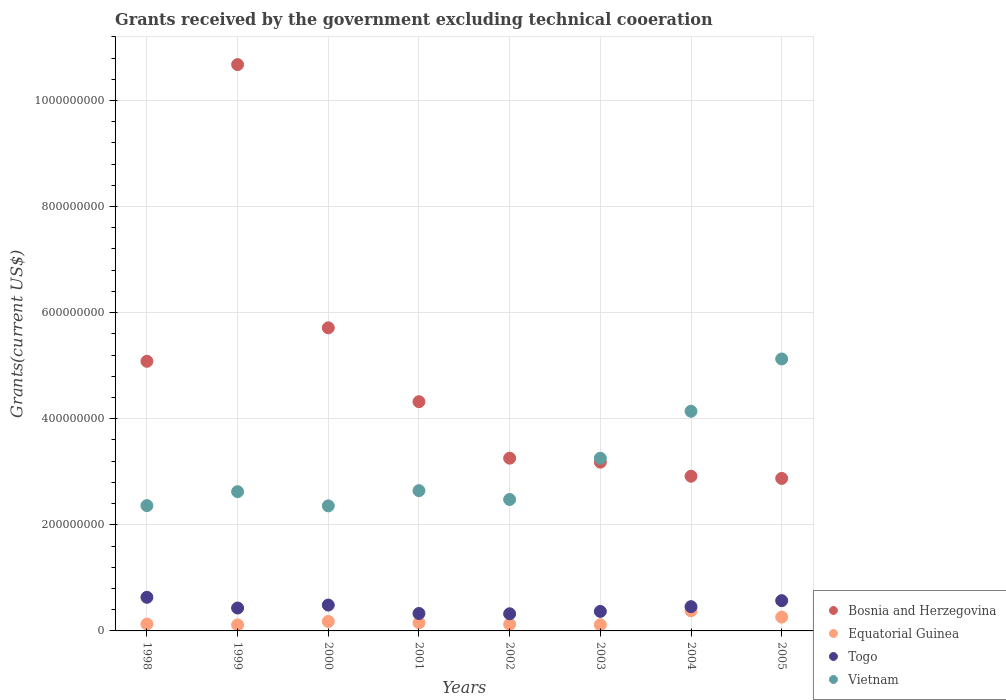What is the total grants received by the government in Vietnam in 1998?
Offer a terse response. 2.36e+08. Across all years, what is the maximum total grants received by the government in Equatorial Guinea?
Ensure brevity in your answer.  3.79e+07. Across all years, what is the minimum total grants received by the government in Vietnam?
Offer a terse response. 2.36e+08. In which year was the total grants received by the government in Togo maximum?
Offer a terse response. 1998. What is the total total grants received by the government in Equatorial Guinea in the graph?
Offer a terse response. 1.46e+08. What is the difference between the total grants received by the government in Vietnam in 1998 and that in 2001?
Make the answer very short. -2.82e+07. What is the difference between the total grants received by the government in Togo in 2003 and the total grants received by the government in Vietnam in 2000?
Offer a terse response. -1.99e+08. What is the average total grants received by the government in Vietnam per year?
Make the answer very short. 3.12e+08. In the year 2004, what is the difference between the total grants received by the government in Vietnam and total grants received by the government in Equatorial Guinea?
Your response must be concise. 3.76e+08. What is the ratio of the total grants received by the government in Vietnam in 1999 to that in 2004?
Offer a terse response. 0.63. Is the difference between the total grants received by the government in Vietnam in 1999 and 2000 greater than the difference between the total grants received by the government in Equatorial Guinea in 1999 and 2000?
Your response must be concise. Yes. What is the difference between the highest and the second highest total grants received by the government in Bosnia and Herzegovina?
Make the answer very short. 4.96e+08. What is the difference between the highest and the lowest total grants received by the government in Vietnam?
Offer a terse response. 2.77e+08. In how many years, is the total grants received by the government in Vietnam greater than the average total grants received by the government in Vietnam taken over all years?
Your answer should be compact. 3. Is the sum of the total grants received by the government in Bosnia and Herzegovina in 1998 and 2003 greater than the maximum total grants received by the government in Vietnam across all years?
Ensure brevity in your answer.  Yes. Is it the case that in every year, the sum of the total grants received by the government in Bosnia and Herzegovina and total grants received by the government in Vietnam  is greater than the sum of total grants received by the government in Togo and total grants received by the government in Equatorial Guinea?
Offer a very short reply. Yes. Is it the case that in every year, the sum of the total grants received by the government in Vietnam and total grants received by the government in Togo  is greater than the total grants received by the government in Equatorial Guinea?
Provide a short and direct response. Yes. Does the total grants received by the government in Bosnia and Herzegovina monotonically increase over the years?
Offer a terse response. No. How many years are there in the graph?
Make the answer very short. 8. What is the difference between two consecutive major ticks on the Y-axis?
Your response must be concise. 2.00e+08. Does the graph contain grids?
Offer a terse response. Yes. How many legend labels are there?
Your answer should be very brief. 4. How are the legend labels stacked?
Offer a very short reply. Vertical. What is the title of the graph?
Provide a succinct answer. Grants received by the government excluding technical cooeration. What is the label or title of the Y-axis?
Give a very brief answer. Grants(current US$). What is the Grants(current US$) in Bosnia and Herzegovina in 1998?
Give a very brief answer. 5.08e+08. What is the Grants(current US$) of Equatorial Guinea in 1998?
Your response must be concise. 1.29e+07. What is the Grants(current US$) in Togo in 1998?
Offer a very short reply. 6.34e+07. What is the Grants(current US$) of Vietnam in 1998?
Make the answer very short. 2.36e+08. What is the Grants(current US$) of Bosnia and Herzegovina in 1999?
Keep it short and to the point. 1.07e+09. What is the Grants(current US$) of Equatorial Guinea in 1999?
Give a very brief answer. 1.13e+07. What is the Grants(current US$) of Togo in 1999?
Offer a terse response. 4.32e+07. What is the Grants(current US$) of Vietnam in 1999?
Ensure brevity in your answer.  2.63e+08. What is the Grants(current US$) of Bosnia and Herzegovina in 2000?
Your answer should be compact. 5.71e+08. What is the Grants(current US$) in Equatorial Guinea in 2000?
Your answer should be very brief. 1.79e+07. What is the Grants(current US$) in Togo in 2000?
Ensure brevity in your answer.  4.88e+07. What is the Grants(current US$) of Vietnam in 2000?
Your response must be concise. 2.36e+08. What is the Grants(current US$) of Bosnia and Herzegovina in 2001?
Provide a short and direct response. 4.32e+08. What is the Grants(current US$) of Equatorial Guinea in 2001?
Your response must be concise. 1.54e+07. What is the Grants(current US$) of Togo in 2001?
Give a very brief answer. 3.29e+07. What is the Grants(current US$) in Vietnam in 2001?
Your answer should be very brief. 2.64e+08. What is the Grants(current US$) in Bosnia and Herzegovina in 2002?
Your response must be concise. 3.26e+08. What is the Grants(current US$) in Equatorial Guinea in 2002?
Keep it short and to the point. 1.25e+07. What is the Grants(current US$) of Togo in 2002?
Make the answer very short. 3.23e+07. What is the Grants(current US$) in Vietnam in 2002?
Provide a succinct answer. 2.48e+08. What is the Grants(current US$) of Bosnia and Herzegovina in 2003?
Ensure brevity in your answer.  3.18e+08. What is the Grants(current US$) of Equatorial Guinea in 2003?
Your response must be concise. 1.16e+07. What is the Grants(current US$) of Togo in 2003?
Your response must be concise. 3.68e+07. What is the Grants(current US$) in Vietnam in 2003?
Your answer should be compact. 3.26e+08. What is the Grants(current US$) of Bosnia and Herzegovina in 2004?
Keep it short and to the point. 2.92e+08. What is the Grants(current US$) in Equatorial Guinea in 2004?
Provide a succinct answer. 3.79e+07. What is the Grants(current US$) in Togo in 2004?
Ensure brevity in your answer.  4.57e+07. What is the Grants(current US$) in Vietnam in 2004?
Offer a terse response. 4.14e+08. What is the Grants(current US$) in Bosnia and Herzegovina in 2005?
Your answer should be compact. 2.88e+08. What is the Grants(current US$) in Equatorial Guinea in 2005?
Keep it short and to the point. 2.61e+07. What is the Grants(current US$) in Togo in 2005?
Your answer should be very brief. 5.70e+07. What is the Grants(current US$) of Vietnam in 2005?
Your answer should be very brief. 5.13e+08. Across all years, what is the maximum Grants(current US$) in Bosnia and Herzegovina?
Make the answer very short. 1.07e+09. Across all years, what is the maximum Grants(current US$) of Equatorial Guinea?
Your answer should be compact. 3.79e+07. Across all years, what is the maximum Grants(current US$) in Togo?
Keep it short and to the point. 6.34e+07. Across all years, what is the maximum Grants(current US$) in Vietnam?
Ensure brevity in your answer.  5.13e+08. Across all years, what is the minimum Grants(current US$) of Bosnia and Herzegovina?
Provide a succinct answer. 2.88e+08. Across all years, what is the minimum Grants(current US$) of Equatorial Guinea?
Provide a succinct answer. 1.13e+07. Across all years, what is the minimum Grants(current US$) in Togo?
Your answer should be compact. 3.23e+07. Across all years, what is the minimum Grants(current US$) in Vietnam?
Provide a succinct answer. 2.36e+08. What is the total Grants(current US$) of Bosnia and Herzegovina in the graph?
Provide a succinct answer. 3.80e+09. What is the total Grants(current US$) of Equatorial Guinea in the graph?
Offer a terse response. 1.46e+08. What is the total Grants(current US$) of Togo in the graph?
Keep it short and to the point. 3.60e+08. What is the total Grants(current US$) of Vietnam in the graph?
Provide a short and direct response. 2.50e+09. What is the difference between the Grants(current US$) of Bosnia and Herzegovina in 1998 and that in 1999?
Your answer should be very brief. -5.59e+08. What is the difference between the Grants(current US$) in Equatorial Guinea in 1998 and that in 1999?
Offer a terse response. 1.65e+06. What is the difference between the Grants(current US$) in Togo in 1998 and that in 1999?
Make the answer very short. 2.02e+07. What is the difference between the Grants(current US$) of Vietnam in 1998 and that in 1999?
Ensure brevity in your answer.  -2.63e+07. What is the difference between the Grants(current US$) of Bosnia and Herzegovina in 1998 and that in 2000?
Your answer should be compact. -6.31e+07. What is the difference between the Grants(current US$) in Equatorial Guinea in 1998 and that in 2000?
Keep it short and to the point. -4.92e+06. What is the difference between the Grants(current US$) of Togo in 1998 and that in 2000?
Make the answer very short. 1.46e+07. What is the difference between the Grants(current US$) in Vietnam in 1998 and that in 2000?
Provide a short and direct response. 5.10e+05. What is the difference between the Grants(current US$) in Bosnia and Herzegovina in 1998 and that in 2001?
Your answer should be very brief. 7.62e+07. What is the difference between the Grants(current US$) of Equatorial Guinea in 1998 and that in 2001?
Provide a succinct answer. -2.46e+06. What is the difference between the Grants(current US$) in Togo in 1998 and that in 2001?
Provide a succinct answer. 3.05e+07. What is the difference between the Grants(current US$) in Vietnam in 1998 and that in 2001?
Offer a terse response. -2.82e+07. What is the difference between the Grants(current US$) of Bosnia and Herzegovina in 1998 and that in 2002?
Your response must be concise. 1.83e+08. What is the difference between the Grants(current US$) of Togo in 1998 and that in 2002?
Keep it short and to the point. 3.11e+07. What is the difference between the Grants(current US$) of Vietnam in 1998 and that in 2002?
Your response must be concise. -1.16e+07. What is the difference between the Grants(current US$) in Bosnia and Herzegovina in 1998 and that in 2003?
Keep it short and to the point. 1.90e+08. What is the difference between the Grants(current US$) in Equatorial Guinea in 1998 and that in 2003?
Your answer should be compact. 1.35e+06. What is the difference between the Grants(current US$) in Togo in 1998 and that in 2003?
Ensure brevity in your answer.  2.66e+07. What is the difference between the Grants(current US$) in Vietnam in 1998 and that in 2003?
Provide a short and direct response. -8.93e+07. What is the difference between the Grants(current US$) in Bosnia and Herzegovina in 1998 and that in 2004?
Ensure brevity in your answer.  2.17e+08. What is the difference between the Grants(current US$) in Equatorial Guinea in 1998 and that in 2004?
Make the answer very short. -2.50e+07. What is the difference between the Grants(current US$) of Togo in 1998 and that in 2004?
Your answer should be compact. 1.76e+07. What is the difference between the Grants(current US$) in Vietnam in 1998 and that in 2004?
Ensure brevity in your answer.  -1.78e+08. What is the difference between the Grants(current US$) of Bosnia and Herzegovina in 1998 and that in 2005?
Your answer should be compact. 2.21e+08. What is the difference between the Grants(current US$) of Equatorial Guinea in 1998 and that in 2005?
Give a very brief answer. -1.31e+07. What is the difference between the Grants(current US$) of Togo in 1998 and that in 2005?
Provide a succinct answer. 6.34e+06. What is the difference between the Grants(current US$) of Vietnam in 1998 and that in 2005?
Offer a terse response. -2.76e+08. What is the difference between the Grants(current US$) in Bosnia and Herzegovina in 1999 and that in 2000?
Your answer should be very brief. 4.96e+08. What is the difference between the Grants(current US$) in Equatorial Guinea in 1999 and that in 2000?
Offer a terse response. -6.57e+06. What is the difference between the Grants(current US$) of Togo in 1999 and that in 2000?
Offer a very short reply. -5.58e+06. What is the difference between the Grants(current US$) of Vietnam in 1999 and that in 2000?
Your answer should be very brief. 2.68e+07. What is the difference between the Grants(current US$) in Bosnia and Herzegovina in 1999 and that in 2001?
Ensure brevity in your answer.  6.35e+08. What is the difference between the Grants(current US$) in Equatorial Guinea in 1999 and that in 2001?
Your answer should be very brief. -4.11e+06. What is the difference between the Grants(current US$) in Togo in 1999 and that in 2001?
Ensure brevity in your answer.  1.03e+07. What is the difference between the Grants(current US$) in Vietnam in 1999 and that in 2001?
Give a very brief answer. -1.88e+06. What is the difference between the Grants(current US$) of Bosnia and Herzegovina in 1999 and that in 2002?
Keep it short and to the point. 7.42e+08. What is the difference between the Grants(current US$) of Equatorial Guinea in 1999 and that in 2002?
Provide a succinct answer. -1.17e+06. What is the difference between the Grants(current US$) in Togo in 1999 and that in 2002?
Offer a terse response. 1.09e+07. What is the difference between the Grants(current US$) in Vietnam in 1999 and that in 2002?
Give a very brief answer. 1.48e+07. What is the difference between the Grants(current US$) of Bosnia and Herzegovina in 1999 and that in 2003?
Provide a short and direct response. 7.49e+08. What is the difference between the Grants(current US$) in Equatorial Guinea in 1999 and that in 2003?
Make the answer very short. -3.00e+05. What is the difference between the Grants(current US$) in Togo in 1999 and that in 2003?
Make the answer very short. 6.42e+06. What is the difference between the Grants(current US$) in Vietnam in 1999 and that in 2003?
Offer a very short reply. -6.30e+07. What is the difference between the Grants(current US$) in Bosnia and Herzegovina in 1999 and that in 2004?
Your answer should be compact. 7.76e+08. What is the difference between the Grants(current US$) in Equatorial Guinea in 1999 and that in 2004?
Provide a short and direct response. -2.66e+07. What is the difference between the Grants(current US$) in Togo in 1999 and that in 2004?
Ensure brevity in your answer.  -2.55e+06. What is the difference between the Grants(current US$) in Vietnam in 1999 and that in 2004?
Provide a short and direct response. -1.52e+08. What is the difference between the Grants(current US$) in Bosnia and Herzegovina in 1999 and that in 2005?
Provide a succinct answer. 7.80e+08. What is the difference between the Grants(current US$) of Equatorial Guinea in 1999 and that in 2005?
Provide a short and direct response. -1.48e+07. What is the difference between the Grants(current US$) in Togo in 1999 and that in 2005?
Offer a terse response. -1.39e+07. What is the difference between the Grants(current US$) of Vietnam in 1999 and that in 2005?
Your answer should be very brief. -2.50e+08. What is the difference between the Grants(current US$) in Bosnia and Herzegovina in 2000 and that in 2001?
Provide a short and direct response. 1.39e+08. What is the difference between the Grants(current US$) in Equatorial Guinea in 2000 and that in 2001?
Offer a very short reply. 2.46e+06. What is the difference between the Grants(current US$) of Togo in 2000 and that in 2001?
Ensure brevity in your answer.  1.59e+07. What is the difference between the Grants(current US$) of Vietnam in 2000 and that in 2001?
Give a very brief answer. -2.87e+07. What is the difference between the Grants(current US$) of Bosnia and Herzegovina in 2000 and that in 2002?
Your answer should be compact. 2.46e+08. What is the difference between the Grants(current US$) of Equatorial Guinea in 2000 and that in 2002?
Offer a terse response. 5.40e+06. What is the difference between the Grants(current US$) in Togo in 2000 and that in 2002?
Your answer should be compact. 1.64e+07. What is the difference between the Grants(current US$) in Vietnam in 2000 and that in 2002?
Offer a very short reply. -1.21e+07. What is the difference between the Grants(current US$) of Bosnia and Herzegovina in 2000 and that in 2003?
Make the answer very short. 2.53e+08. What is the difference between the Grants(current US$) in Equatorial Guinea in 2000 and that in 2003?
Provide a succinct answer. 6.27e+06. What is the difference between the Grants(current US$) of Togo in 2000 and that in 2003?
Make the answer very short. 1.20e+07. What is the difference between the Grants(current US$) in Vietnam in 2000 and that in 2003?
Make the answer very short. -8.98e+07. What is the difference between the Grants(current US$) of Bosnia and Herzegovina in 2000 and that in 2004?
Ensure brevity in your answer.  2.80e+08. What is the difference between the Grants(current US$) of Equatorial Guinea in 2000 and that in 2004?
Keep it short and to the point. -2.00e+07. What is the difference between the Grants(current US$) in Togo in 2000 and that in 2004?
Provide a succinct answer. 3.03e+06. What is the difference between the Grants(current US$) of Vietnam in 2000 and that in 2004?
Give a very brief answer. -1.78e+08. What is the difference between the Grants(current US$) of Bosnia and Herzegovina in 2000 and that in 2005?
Keep it short and to the point. 2.84e+08. What is the difference between the Grants(current US$) in Equatorial Guinea in 2000 and that in 2005?
Provide a succinct answer. -8.20e+06. What is the difference between the Grants(current US$) in Togo in 2000 and that in 2005?
Give a very brief answer. -8.28e+06. What is the difference between the Grants(current US$) in Vietnam in 2000 and that in 2005?
Your answer should be compact. -2.77e+08. What is the difference between the Grants(current US$) in Bosnia and Herzegovina in 2001 and that in 2002?
Offer a terse response. 1.06e+08. What is the difference between the Grants(current US$) in Equatorial Guinea in 2001 and that in 2002?
Your response must be concise. 2.94e+06. What is the difference between the Grants(current US$) of Togo in 2001 and that in 2002?
Your answer should be very brief. 5.50e+05. What is the difference between the Grants(current US$) in Vietnam in 2001 and that in 2002?
Ensure brevity in your answer.  1.66e+07. What is the difference between the Grants(current US$) in Bosnia and Herzegovina in 2001 and that in 2003?
Offer a terse response. 1.14e+08. What is the difference between the Grants(current US$) of Equatorial Guinea in 2001 and that in 2003?
Your response must be concise. 3.81e+06. What is the difference between the Grants(current US$) in Togo in 2001 and that in 2003?
Keep it short and to the point. -3.90e+06. What is the difference between the Grants(current US$) of Vietnam in 2001 and that in 2003?
Keep it short and to the point. -6.11e+07. What is the difference between the Grants(current US$) in Bosnia and Herzegovina in 2001 and that in 2004?
Make the answer very short. 1.40e+08. What is the difference between the Grants(current US$) of Equatorial Guinea in 2001 and that in 2004?
Your answer should be compact. -2.25e+07. What is the difference between the Grants(current US$) in Togo in 2001 and that in 2004?
Make the answer very short. -1.29e+07. What is the difference between the Grants(current US$) in Vietnam in 2001 and that in 2004?
Your answer should be very brief. -1.50e+08. What is the difference between the Grants(current US$) of Bosnia and Herzegovina in 2001 and that in 2005?
Give a very brief answer. 1.45e+08. What is the difference between the Grants(current US$) of Equatorial Guinea in 2001 and that in 2005?
Offer a very short reply. -1.07e+07. What is the difference between the Grants(current US$) of Togo in 2001 and that in 2005?
Provide a succinct answer. -2.42e+07. What is the difference between the Grants(current US$) in Vietnam in 2001 and that in 2005?
Offer a very short reply. -2.48e+08. What is the difference between the Grants(current US$) of Bosnia and Herzegovina in 2002 and that in 2003?
Provide a short and direct response. 7.51e+06. What is the difference between the Grants(current US$) in Equatorial Guinea in 2002 and that in 2003?
Your answer should be very brief. 8.70e+05. What is the difference between the Grants(current US$) in Togo in 2002 and that in 2003?
Your response must be concise. -4.45e+06. What is the difference between the Grants(current US$) in Vietnam in 2002 and that in 2003?
Make the answer very short. -7.77e+07. What is the difference between the Grants(current US$) of Bosnia and Herzegovina in 2002 and that in 2004?
Provide a succinct answer. 3.40e+07. What is the difference between the Grants(current US$) of Equatorial Guinea in 2002 and that in 2004?
Your answer should be very brief. -2.54e+07. What is the difference between the Grants(current US$) in Togo in 2002 and that in 2004?
Provide a succinct answer. -1.34e+07. What is the difference between the Grants(current US$) in Vietnam in 2002 and that in 2004?
Your answer should be compact. -1.66e+08. What is the difference between the Grants(current US$) of Bosnia and Herzegovina in 2002 and that in 2005?
Your answer should be compact. 3.81e+07. What is the difference between the Grants(current US$) of Equatorial Guinea in 2002 and that in 2005?
Keep it short and to the point. -1.36e+07. What is the difference between the Grants(current US$) in Togo in 2002 and that in 2005?
Provide a succinct answer. -2.47e+07. What is the difference between the Grants(current US$) in Vietnam in 2002 and that in 2005?
Give a very brief answer. -2.65e+08. What is the difference between the Grants(current US$) of Bosnia and Herzegovina in 2003 and that in 2004?
Give a very brief answer. 2.65e+07. What is the difference between the Grants(current US$) in Equatorial Guinea in 2003 and that in 2004?
Offer a terse response. -2.63e+07. What is the difference between the Grants(current US$) in Togo in 2003 and that in 2004?
Provide a short and direct response. -8.97e+06. What is the difference between the Grants(current US$) in Vietnam in 2003 and that in 2004?
Your answer should be very brief. -8.85e+07. What is the difference between the Grants(current US$) of Bosnia and Herzegovina in 2003 and that in 2005?
Keep it short and to the point. 3.06e+07. What is the difference between the Grants(current US$) of Equatorial Guinea in 2003 and that in 2005?
Your answer should be compact. -1.45e+07. What is the difference between the Grants(current US$) of Togo in 2003 and that in 2005?
Provide a short and direct response. -2.03e+07. What is the difference between the Grants(current US$) of Vietnam in 2003 and that in 2005?
Provide a short and direct response. -1.87e+08. What is the difference between the Grants(current US$) of Bosnia and Herzegovina in 2004 and that in 2005?
Offer a terse response. 4.10e+06. What is the difference between the Grants(current US$) of Equatorial Guinea in 2004 and that in 2005?
Provide a short and direct response. 1.18e+07. What is the difference between the Grants(current US$) of Togo in 2004 and that in 2005?
Provide a short and direct response. -1.13e+07. What is the difference between the Grants(current US$) of Vietnam in 2004 and that in 2005?
Make the answer very short. -9.86e+07. What is the difference between the Grants(current US$) in Bosnia and Herzegovina in 1998 and the Grants(current US$) in Equatorial Guinea in 1999?
Give a very brief answer. 4.97e+08. What is the difference between the Grants(current US$) of Bosnia and Herzegovina in 1998 and the Grants(current US$) of Togo in 1999?
Provide a succinct answer. 4.65e+08. What is the difference between the Grants(current US$) of Bosnia and Herzegovina in 1998 and the Grants(current US$) of Vietnam in 1999?
Your answer should be compact. 2.46e+08. What is the difference between the Grants(current US$) of Equatorial Guinea in 1998 and the Grants(current US$) of Togo in 1999?
Your answer should be very brief. -3.02e+07. What is the difference between the Grants(current US$) of Equatorial Guinea in 1998 and the Grants(current US$) of Vietnam in 1999?
Provide a short and direct response. -2.50e+08. What is the difference between the Grants(current US$) of Togo in 1998 and the Grants(current US$) of Vietnam in 1999?
Offer a very short reply. -1.99e+08. What is the difference between the Grants(current US$) in Bosnia and Herzegovina in 1998 and the Grants(current US$) in Equatorial Guinea in 2000?
Make the answer very short. 4.90e+08. What is the difference between the Grants(current US$) in Bosnia and Herzegovina in 1998 and the Grants(current US$) in Togo in 2000?
Give a very brief answer. 4.60e+08. What is the difference between the Grants(current US$) in Bosnia and Herzegovina in 1998 and the Grants(current US$) in Vietnam in 2000?
Offer a very short reply. 2.73e+08. What is the difference between the Grants(current US$) of Equatorial Guinea in 1998 and the Grants(current US$) of Togo in 2000?
Provide a short and direct response. -3.58e+07. What is the difference between the Grants(current US$) of Equatorial Guinea in 1998 and the Grants(current US$) of Vietnam in 2000?
Ensure brevity in your answer.  -2.23e+08. What is the difference between the Grants(current US$) of Togo in 1998 and the Grants(current US$) of Vietnam in 2000?
Ensure brevity in your answer.  -1.72e+08. What is the difference between the Grants(current US$) in Bosnia and Herzegovina in 1998 and the Grants(current US$) in Equatorial Guinea in 2001?
Your response must be concise. 4.93e+08. What is the difference between the Grants(current US$) of Bosnia and Herzegovina in 1998 and the Grants(current US$) of Togo in 2001?
Offer a terse response. 4.75e+08. What is the difference between the Grants(current US$) of Bosnia and Herzegovina in 1998 and the Grants(current US$) of Vietnam in 2001?
Provide a succinct answer. 2.44e+08. What is the difference between the Grants(current US$) of Equatorial Guinea in 1998 and the Grants(current US$) of Togo in 2001?
Your response must be concise. -1.99e+07. What is the difference between the Grants(current US$) in Equatorial Guinea in 1998 and the Grants(current US$) in Vietnam in 2001?
Ensure brevity in your answer.  -2.51e+08. What is the difference between the Grants(current US$) in Togo in 1998 and the Grants(current US$) in Vietnam in 2001?
Provide a succinct answer. -2.01e+08. What is the difference between the Grants(current US$) of Bosnia and Herzegovina in 1998 and the Grants(current US$) of Equatorial Guinea in 2002?
Your response must be concise. 4.96e+08. What is the difference between the Grants(current US$) in Bosnia and Herzegovina in 1998 and the Grants(current US$) in Togo in 2002?
Ensure brevity in your answer.  4.76e+08. What is the difference between the Grants(current US$) in Bosnia and Herzegovina in 1998 and the Grants(current US$) in Vietnam in 2002?
Give a very brief answer. 2.61e+08. What is the difference between the Grants(current US$) of Equatorial Guinea in 1998 and the Grants(current US$) of Togo in 2002?
Your answer should be very brief. -1.94e+07. What is the difference between the Grants(current US$) in Equatorial Guinea in 1998 and the Grants(current US$) in Vietnam in 2002?
Offer a terse response. -2.35e+08. What is the difference between the Grants(current US$) in Togo in 1998 and the Grants(current US$) in Vietnam in 2002?
Give a very brief answer. -1.84e+08. What is the difference between the Grants(current US$) in Bosnia and Herzegovina in 1998 and the Grants(current US$) in Equatorial Guinea in 2003?
Provide a short and direct response. 4.97e+08. What is the difference between the Grants(current US$) of Bosnia and Herzegovina in 1998 and the Grants(current US$) of Togo in 2003?
Your answer should be very brief. 4.72e+08. What is the difference between the Grants(current US$) in Bosnia and Herzegovina in 1998 and the Grants(current US$) in Vietnam in 2003?
Provide a succinct answer. 1.83e+08. What is the difference between the Grants(current US$) in Equatorial Guinea in 1998 and the Grants(current US$) in Togo in 2003?
Make the answer very short. -2.38e+07. What is the difference between the Grants(current US$) of Equatorial Guinea in 1998 and the Grants(current US$) of Vietnam in 2003?
Provide a succinct answer. -3.13e+08. What is the difference between the Grants(current US$) in Togo in 1998 and the Grants(current US$) in Vietnam in 2003?
Offer a very short reply. -2.62e+08. What is the difference between the Grants(current US$) in Bosnia and Herzegovina in 1998 and the Grants(current US$) in Equatorial Guinea in 2004?
Make the answer very short. 4.70e+08. What is the difference between the Grants(current US$) of Bosnia and Herzegovina in 1998 and the Grants(current US$) of Togo in 2004?
Your response must be concise. 4.63e+08. What is the difference between the Grants(current US$) of Bosnia and Herzegovina in 1998 and the Grants(current US$) of Vietnam in 2004?
Offer a very short reply. 9.42e+07. What is the difference between the Grants(current US$) in Equatorial Guinea in 1998 and the Grants(current US$) in Togo in 2004?
Provide a short and direct response. -3.28e+07. What is the difference between the Grants(current US$) in Equatorial Guinea in 1998 and the Grants(current US$) in Vietnam in 2004?
Provide a succinct answer. -4.01e+08. What is the difference between the Grants(current US$) in Togo in 1998 and the Grants(current US$) in Vietnam in 2004?
Your answer should be very brief. -3.51e+08. What is the difference between the Grants(current US$) of Bosnia and Herzegovina in 1998 and the Grants(current US$) of Equatorial Guinea in 2005?
Provide a short and direct response. 4.82e+08. What is the difference between the Grants(current US$) in Bosnia and Herzegovina in 1998 and the Grants(current US$) in Togo in 2005?
Provide a succinct answer. 4.51e+08. What is the difference between the Grants(current US$) in Bosnia and Herzegovina in 1998 and the Grants(current US$) in Vietnam in 2005?
Offer a very short reply. -4.37e+06. What is the difference between the Grants(current US$) of Equatorial Guinea in 1998 and the Grants(current US$) of Togo in 2005?
Your response must be concise. -4.41e+07. What is the difference between the Grants(current US$) in Equatorial Guinea in 1998 and the Grants(current US$) in Vietnam in 2005?
Offer a very short reply. -5.00e+08. What is the difference between the Grants(current US$) in Togo in 1998 and the Grants(current US$) in Vietnam in 2005?
Provide a short and direct response. -4.49e+08. What is the difference between the Grants(current US$) in Bosnia and Herzegovina in 1999 and the Grants(current US$) in Equatorial Guinea in 2000?
Your response must be concise. 1.05e+09. What is the difference between the Grants(current US$) of Bosnia and Herzegovina in 1999 and the Grants(current US$) of Togo in 2000?
Your answer should be very brief. 1.02e+09. What is the difference between the Grants(current US$) in Bosnia and Herzegovina in 1999 and the Grants(current US$) in Vietnam in 2000?
Offer a very short reply. 8.32e+08. What is the difference between the Grants(current US$) of Equatorial Guinea in 1999 and the Grants(current US$) of Togo in 2000?
Your response must be concise. -3.75e+07. What is the difference between the Grants(current US$) of Equatorial Guinea in 1999 and the Grants(current US$) of Vietnam in 2000?
Make the answer very short. -2.24e+08. What is the difference between the Grants(current US$) of Togo in 1999 and the Grants(current US$) of Vietnam in 2000?
Provide a short and direct response. -1.93e+08. What is the difference between the Grants(current US$) of Bosnia and Herzegovina in 1999 and the Grants(current US$) of Equatorial Guinea in 2001?
Your answer should be compact. 1.05e+09. What is the difference between the Grants(current US$) in Bosnia and Herzegovina in 1999 and the Grants(current US$) in Togo in 2001?
Offer a terse response. 1.03e+09. What is the difference between the Grants(current US$) of Bosnia and Herzegovina in 1999 and the Grants(current US$) of Vietnam in 2001?
Offer a terse response. 8.03e+08. What is the difference between the Grants(current US$) of Equatorial Guinea in 1999 and the Grants(current US$) of Togo in 2001?
Your answer should be compact. -2.16e+07. What is the difference between the Grants(current US$) in Equatorial Guinea in 1999 and the Grants(current US$) in Vietnam in 2001?
Provide a short and direct response. -2.53e+08. What is the difference between the Grants(current US$) of Togo in 1999 and the Grants(current US$) of Vietnam in 2001?
Provide a short and direct response. -2.21e+08. What is the difference between the Grants(current US$) in Bosnia and Herzegovina in 1999 and the Grants(current US$) in Equatorial Guinea in 2002?
Your answer should be compact. 1.06e+09. What is the difference between the Grants(current US$) in Bosnia and Herzegovina in 1999 and the Grants(current US$) in Togo in 2002?
Offer a terse response. 1.04e+09. What is the difference between the Grants(current US$) of Bosnia and Herzegovina in 1999 and the Grants(current US$) of Vietnam in 2002?
Keep it short and to the point. 8.20e+08. What is the difference between the Grants(current US$) of Equatorial Guinea in 1999 and the Grants(current US$) of Togo in 2002?
Provide a short and direct response. -2.10e+07. What is the difference between the Grants(current US$) of Equatorial Guinea in 1999 and the Grants(current US$) of Vietnam in 2002?
Give a very brief answer. -2.36e+08. What is the difference between the Grants(current US$) in Togo in 1999 and the Grants(current US$) in Vietnam in 2002?
Provide a succinct answer. -2.05e+08. What is the difference between the Grants(current US$) in Bosnia and Herzegovina in 1999 and the Grants(current US$) in Equatorial Guinea in 2003?
Give a very brief answer. 1.06e+09. What is the difference between the Grants(current US$) of Bosnia and Herzegovina in 1999 and the Grants(current US$) of Togo in 2003?
Make the answer very short. 1.03e+09. What is the difference between the Grants(current US$) in Bosnia and Herzegovina in 1999 and the Grants(current US$) in Vietnam in 2003?
Make the answer very short. 7.42e+08. What is the difference between the Grants(current US$) in Equatorial Guinea in 1999 and the Grants(current US$) in Togo in 2003?
Make the answer very short. -2.55e+07. What is the difference between the Grants(current US$) of Equatorial Guinea in 1999 and the Grants(current US$) of Vietnam in 2003?
Ensure brevity in your answer.  -3.14e+08. What is the difference between the Grants(current US$) of Togo in 1999 and the Grants(current US$) of Vietnam in 2003?
Give a very brief answer. -2.82e+08. What is the difference between the Grants(current US$) of Bosnia and Herzegovina in 1999 and the Grants(current US$) of Equatorial Guinea in 2004?
Ensure brevity in your answer.  1.03e+09. What is the difference between the Grants(current US$) in Bosnia and Herzegovina in 1999 and the Grants(current US$) in Togo in 2004?
Your answer should be compact. 1.02e+09. What is the difference between the Grants(current US$) of Bosnia and Herzegovina in 1999 and the Grants(current US$) of Vietnam in 2004?
Offer a terse response. 6.54e+08. What is the difference between the Grants(current US$) in Equatorial Guinea in 1999 and the Grants(current US$) in Togo in 2004?
Offer a very short reply. -3.44e+07. What is the difference between the Grants(current US$) of Equatorial Guinea in 1999 and the Grants(current US$) of Vietnam in 2004?
Keep it short and to the point. -4.03e+08. What is the difference between the Grants(current US$) of Togo in 1999 and the Grants(current US$) of Vietnam in 2004?
Your answer should be very brief. -3.71e+08. What is the difference between the Grants(current US$) in Bosnia and Herzegovina in 1999 and the Grants(current US$) in Equatorial Guinea in 2005?
Provide a succinct answer. 1.04e+09. What is the difference between the Grants(current US$) in Bosnia and Herzegovina in 1999 and the Grants(current US$) in Togo in 2005?
Make the answer very short. 1.01e+09. What is the difference between the Grants(current US$) of Bosnia and Herzegovina in 1999 and the Grants(current US$) of Vietnam in 2005?
Provide a succinct answer. 5.55e+08. What is the difference between the Grants(current US$) in Equatorial Guinea in 1999 and the Grants(current US$) in Togo in 2005?
Provide a short and direct response. -4.58e+07. What is the difference between the Grants(current US$) in Equatorial Guinea in 1999 and the Grants(current US$) in Vietnam in 2005?
Make the answer very short. -5.01e+08. What is the difference between the Grants(current US$) in Togo in 1999 and the Grants(current US$) in Vietnam in 2005?
Offer a very short reply. -4.69e+08. What is the difference between the Grants(current US$) of Bosnia and Herzegovina in 2000 and the Grants(current US$) of Equatorial Guinea in 2001?
Keep it short and to the point. 5.56e+08. What is the difference between the Grants(current US$) in Bosnia and Herzegovina in 2000 and the Grants(current US$) in Togo in 2001?
Provide a short and direct response. 5.38e+08. What is the difference between the Grants(current US$) of Bosnia and Herzegovina in 2000 and the Grants(current US$) of Vietnam in 2001?
Give a very brief answer. 3.07e+08. What is the difference between the Grants(current US$) of Equatorial Guinea in 2000 and the Grants(current US$) of Togo in 2001?
Your response must be concise. -1.50e+07. What is the difference between the Grants(current US$) of Equatorial Guinea in 2000 and the Grants(current US$) of Vietnam in 2001?
Your response must be concise. -2.47e+08. What is the difference between the Grants(current US$) of Togo in 2000 and the Grants(current US$) of Vietnam in 2001?
Your response must be concise. -2.16e+08. What is the difference between the Grants(current US$) of Bosnia and Herzegovina in 2000 and the Grants(current US$) of Equatorial Guinea in 2002?
Keep it short and to the point. 5.59e+08. What is the difference between the Grants(current US$) of Bosnia and Herzegovina in 2000 and the Grants(current US$) of Togo in 2002?
Your answer should be very brief. 5.39e+08. What is the difference between the Grants(current US$) of Bosnia and Herzegovina in 2000 and the Grants(current US$) of Vietnam in 2002?
Provide a short and direct response. 3.24e+08. What is the difference between the Grants(current US$) in Equatorial Guinea in 2000 and the Grants(current US$) in Togo in 2002?
Provide a succinct answer. -1.45e+07. What is the difference between the Grants(current US$) in Equatorial Guinea in 2000 and the Grants(current US$) in Vietnam in 2002?
Your answer should be compact. -2.30e+08. What is the difference between the Grants(current US$) of Togo in 2000 and the Grants(current US$) of Vietnam in 2002?
Provide a succinct answer. -1.99e+08. What is the difference between the Grants(current US$) in Bosnia and Herzegovina in 2000 and the Grants(current US$) in Equatorial Guinea in 2003?
Your answer should be very brief. 5.60e+08. What is the difference between the Grants(current US$) in Bosnia and Herzegovina in 2000 and the Grants(current US$) in Togo in 2003?
Make the answer very short. 5.35e+08. What is the difference between the Grants(current US$) in Bosnia and Herzegovina in 2000 and the Grants(current US$) in Vietnam in 2003?
Offer a very short reply. 2.46e+08. What is the difference between the Grants(current US$) in Equatorial Guinea in 2000 and the Grants(current US$) in Togo in 2003?
Offer a very short reply. -1.89e+07. What is the difference between the Grants(current US$) in Equatorial Guinea in 2000 and the Grants(current US$) in Vietnam in 2003?
Your response must be concise. -3.08e+08. What is the difference between the Grants(current US$) of Togo in 2000 and the Grants(current US$) of Vietnam in 2003?
Keep it short and to the point. -2.77e+08. What is the difference between the Grants(current US$) in Bosnia and Herzegovina in 2000 and the Grants(current US$) in Equatorial Guinea in 2004?
Give a very brief answer. 5.33e+08. What is the difference between the Grants(current US$) in Bosnia and Herzegovina in 2000 and the Grants(current US$) in Togo in 2004?
Provide a short and direct response. 5.26e+08. What is the difference between the Grants(current US$) of Bosnia and Herzegovina in 2000 and the Grants(current US$) of Vietnam in 2004?
Provide a short and direct response. 1.57e+08. What is the difference between the Grants(current US$) in Equatorial Guinea in 2000 and the Grants(current US$) in Togo in 2004?
Offer a very short reply. -2.79e+07. What is the difference between the Grants(current US$) of Equatorial Guinea in 2000 and the Grants(current US$) of Vietnam in 2004?
Ensure brevity in your answer.  -3.96e+08. What is the difference between the Grants(current US$) in Togo in 2000 and the Grants(current US$) in Vietnam in 2004?
Give a very brief answer. -3.65e+08. What is the difference between the Grants(current US$) in Bosnia and Herzegovina in 2000 and the Grants(current US$) in Equatorial Guinea in 2005?
Ensure brevity in your answer.  5.45e+08. What is the difference between the Grants(current US$) in Bosnia and Herzegovina in 2000 and the Grants(current US$) in Togo in 2005?
Your response must be concise. 5.14e+08. What is the difference between the Grants(current US$) of Bosnia and Herzegovina in 2000 and the Grants(current US$) of Vietnam in 2005?
Give a very brief answer. 5.87e+07. What is the difference between the Grants(current US$) in Equatorial Guinea in 2000 and the Grants(current US$) in Togo in 2005?
Ensure brevity in your answer.  -3.92e+07. What is the difference between the Grants(current US$) in Equatorial Guinea in 2000 and the Grants(current US$) in Vietnam in 2005?
Your response must be concise. -4.95e+08. What is the difference between the Grants(current US$) of Togo in 2000 and the Grants(current US$) of Vietnam in 2005?
Ensure brevity in your answer.  -4.64e+08. What is the difference between the Grants(current US$) in Bosnia and Herzegovina in 2001 and the Grants(current US$) in Equatorial Guinea in 2002?
Provide a succinct answer. 4.20e+08. What is the difference between the Grants(current US$) in Bosnia and Herzegovina in 2001 and the Grants(current US$) in Togo in 2002?
Offer a very short reply. 4.00e+08. What is the difference between the Grants(current US$) in Bosnia and Herzegovina in 2001 and the Grants(current US$) in Vietnam in 2002?
Your answer should be very brief. 1.84e+08. What is the difference between the Grants(current US$) of Equatorial Guinea in 2001 and the Grants(current US$) of Togo in 2002?
Your answer should be compact. -1.69e+07. What is the difference between the Grants(current US$) of Equatorial Guinea in 2001 and the Grants(current US$) of Vietnam in 2002?
Ensure brevity in your answer.  -2.32e+08. What is the difference between the Grants(current US$) of Togo in 2001 and the Grants(current US$) of Vietnam in 2002?
Give a very brief answer. -2.15e+08. What is the difference between the Grants(current US$) of Bosnia and Herzegovina in 2001 and the Grants(current US$) of Equatorial Guinea in 2003?
Your answer should be compact. 4.21e+08. What is the difference between the Grants(current US$) of Bosnia and Herzegovina in 2001 and the Grants(current US$) of Togo in 2003?
Provide a succinct answer. 3.95e+08. What is the difference between the Grants(current US$) in Bosnia and Herzegovina in 2001 and the Grants(current US$) in Vietnam in 2003?
Offer a terse response. 1.07e+08. What is the difference between the Grants(current US$) in Equatorial Guinea in 2001 and the Grants(current US$) in Togo in 2003?
Make the answer very short. -2.14e+07. What is the difference between the Grants(current US$) in Equatorial Guinea in 2001 and the Grants(current US$) in Vietnam in 2003?
Offer a very short reply. -3.10e+08. What is the difference between the Grants(current US$) of Togo in 2001 and the Grants(current US$) of Vietnam in 2003?
Provide a short and direct response. -2.93e+08. What is the difference between the Grants(current US$) of Bosnia and Herzegovina in 2001 and the Grants(current US$) of Equatorial Guinea in 2004?
Make the answer very short. 3.94e+08. What is the difference between the Grants(current US$) in Bosnia and Herzegovina in 2001 and the Grants(current US$) in Togo in 2004?
Keep it short and to the point. 3.86e+08. What is the difference between the Grants(current US$) in Bosnia and Herzegovina in 2001 and the Grants(current US$) in Vietnam in 2004?
Provide a short and direct response. 1.81e+07. What is the difference between the Grants(current US$) of Equatorial Guinea in 2001 and the Grants(current US$) of Togo in 2004?
Provide a succinct answer. -3.03e+07. What is the difference between the Grants(current US$) in Equatorial Guinea in 2001 and the Grants(current US$) in Vietnam in 2004?
Make the answer very short. -3.99e+08. What is the difference between the Grants(current US$) in Togo in 2001 and the Grants(current US$) in Vietnam in 2004?
Provide a short and direct response. -3.81e+08. What is the difference between the Grants(current US$) of Bosnia and Herzegovina in 2001 and the Grants(current US$) of Equatorial Guinea in 2005?
Provide a short and direct response. 4.06e+08. What is the difference between the Grants(current US$) of Bosnia and Herzegovina in 2001 and the Grants(current US$) of Togo in 2005?
Ensure brevity in your answer.  3.75e+08. What is the difference between the Grants(current US$) of Bosnia and Herzegovina in 2001 and the Grants(current US$) of Vietnam in 2005?
Make the answer very short. -8.05e+07. What is the difference between the Grants(current US$) of Equatorial Guinea in 2001 and the Grants(current US$) of Togo in 2005?
Make the answer very short. -4.16e+07. What is the difference between the Grants(current US$) of Equatorial Guinea in 2001 and the Grants(current US$) of Vietnam in 2005?
Your answer should be very brief. -4.97e+08. What is the difference between the Grants(current US$) in Togo in 2001 and the Grants(current US$) in Vietnam in 2005?
Make the answer very short. -4.80e+08. What is the difference between the Grants(current US$) of Bosnia and Herzegovina in 2002 and the Grants(current US$) of Equatorial Guinea in 2003?
Provide a short and direct response. 3.14e+08. What is the difference between the Grants(current US$) of Bosnia and Herzegovina in 2002 and the Grants(current US$) of Togo in 2003?
Make the answer very short. 2.89e+08. What is the difference between the Grants(current US$) in Bosnia and Herzegovina in 2002 and the Grants(current US$) in Vietnam in 2003?
Your response must be concise. 1.40e+05. What is the difference between the Grants(current US$) of Equatorial Guinea in 2002 and the Grants(current US$) of Togo in 2003?
Provide a succinct answer. -2.43e+07. What is the difference between the Grants(current US$) of Equatorial Guinea in 2002 and the Grants(current US$) of Vietnam in 2003?
Give a very brief answer. -3.13e+08. What is the difference between the Grants(current US$) of Togo in 2002 and the Grants(current US$) of Vietnam in 2003?
Your answer should be very brief. -2.93e+08. What is the difference between the Grants(current US$) of Bosnia and Herzegovina in 2002 and the Grants(current US$) of Equatorial Guinea in 2004?
Keep it short and to the point. 2.88e+08. What is the difference between the Grants(current US$) in Bosnia and Herzegovina in 2002 and the Grants(current US$) in Togo in 2004?
Your answer should be very brief. 2.80e+08. What is the difference between the Grants(current US$) of Bosnia and Herzegovina in 2002 and the Grants(current US$) of Vietnam in 2004?
Provide a succinct answer. -8.84e+07. What is the difference between the Grants(current US$) of Equatorial Guinea in 2002 and the Grants(current US$) of Togo in 2004?
Ensure brevity in your answer.  -3.33e+07. What is the difference between the Grants(current US$) of Equatorial Guinea in 2002 and the Grants(current US$) of Vietnam in 2004?
Give a very brief answer. -4.02e+08. What is the difference between the Grants(current US$) in Togo in 2002 and the Grants(current US$) in Vietnam in 2004?
Your response must be concise. -3.82e+08. What is the difference between the Grants(current US$) of Bosnia and Herzegovina in 2002 and the Grants(current US$) of Equatorial Guinea in 2005?
Offer a very short reply. 3.00e+08. What is the difference between the Grants(current US$) of Bosnia and Herzegovina in 2002 and the Grants(current US$) of Togo in 2005?
Your answer should be very brief. 2.69e+08. What is the difference between the Grants(current US$) of Bosnia and Herzegovina in 2002 and the Grants(current US$) of Vietnam in 2005?
Keep it short and to the point. -1.87e+08. What is the difference between the Grants(current US$) of Equatorial Guinea in 2002 and the Grants(current US$) of Togo in 2005?
Your answer should be very brief. -4.46e+07. What is the difference between the Grants(current US$) in Equatorial Guinea in 2002 and the Grants(current US$) in Vietnam in 2005?
Your response must be concise. -5.00e+08. What is the difference between the Grants(current US$) in Togo in 2002 and the Grants(current US$) in Vietnam in 2005?
Keep it short and to the point. -4.80e+08. What is the difference between the Grants(current US$) in Bosnia and Herzegovina in 2003 and the Grants(current US$) in Equatorial Guinea in 2004?
Offer a very short reply. 2.80e+08. What is the difference between the Grants(current US$) in Bosnia and Herzegovina in 2003 and the Grants(current US$) in Togo in 2004?
Your answer should be compact. 2.72e+08. What is the difference between the Grants(current US$) of Bosnia and Herzegovina in 2003 and the Grants(current US$) of Vietnam in 2004?
Your response must be concise. -9.59e+07. What is the difference between the Grants(current US$) in Equatorial Guinea in 2003 and the Grants(current US$) in Togo in 2004?
Make the answer very short. -3.42e+07. What is the difference between the Grants(current US$) in Equatorial Guinea in 2003 and the Grants(current US$) in Vietnam in 2004?
Your response must be concise. -4.02e+08. What is the difference between the Grants(current US$) of Togo in 2003 and the Grants(current US$) of Vietnam in 2004?
Give a very brief answer. -3.77e+08. What is the difference between the Grants(current US$) in Bosnia and Herzegovina in 2003 and the Grants(current US$) in Equatorial Guinea in 2005?
Keep it short and to the point. 2.92e+08. What is the difference between the Grants(current US$) in Bosnia and Herzegovina in 2003 and the Grants(current US$) in Togo in 2005?
Your answer should be compact. 2.61e+08. What is the difference between the Grants(current US$) of Bosnia and Herzegovina in 2003 and the Grants(current US$) of Vietnam in 2005?
Your answer should be compact. -1.95e+08. What is the difference between the Grants(current US$) in Equatorial Guinea in 2003 and the Grants(current US$) in Togo in 2005?
Provide a succinct answer. -4.55e+07. What is the difference between the Grants(current US$) of Equatorial Guinea in 2003 and the Grants(current US$) of Vietnam in 2005?
Offer a very short reply. -5.01e+08. What is the difference between the Grants(current US$) of Togo in 2003 and the Grants(current US$) of Vietnam in 2005?
Make the answer very short. -4.76e+08. What is the difference between the Grants(current US$) in Bosnia and Herzegovina in 2004 and the Grants(current US$) in Equatorial Guinea in 2005?
Give a very brief answer. 2.66e+08. What is the difference between the Grants(current US$) in Bosnia and Herzegovina in 2004 and the Grants(current US$) in Togo in 2005?
Provide a succinct answer. 2.35e+08. What is the difference between the Grants(current US$) in Bosnia and Herzegovina in 2004 and the Grants(current US$) in Vietnam in 2005?
Make the answer very short. -2.21e+08. What is the difference between the Grants(current US$) of Equatorial Guinea in 2004 and the Grants(current US$) of Togo in 2005?
Your response must be concise. -1.92e+07. What is the difference between the Grants(current US$) in Equatorial Guinea in 2004 and the Grants(current US$) in Vietnam in 2005?
Offer a very short reply. -4.75e+08. What is the difference between the Grants(current US$) in Togo in 2004 and the Grants(current US$) in Vietnam in 2005?
Keep it short and to the point. -4.67e+08. What is the average Grants(current US$) of Bosnia and Herzegovina per year?
Provide a short and direct response. 4.75e+08. What is the average Grants(current US$) of Equatorial Guinea per year?
Provide a succinct answer. 1.82e+07. What is the average Grants(current US$) of Togo per year?
Make the answer very short. 4.50e+07. What is the average Grants(current US$) of Vietnam per year?
Provide a succinct answer. 3.12e+08. In the year 1998, what is the difference between the Grants(current US$) in Bosnia and Herzegovina and Grants(current US$) in Equatorial Guinea?
Provide a succinct answer. 4.95e+08. In the year 1998, what is the difference between the Grants(current US$) in Bosnia and Herzegovina and Grants(current US$) in Togo?
Ensure brevity in your answer.  4.45e+08. In the year 1998, what is the difference between the Grants(current US$) in Bosnia and Herzegovina and Grants(current US$) in Vietnam?
Keep it short and to the point. 2.72e+08. In the year 1998, what is the difference between the Grants(current US$) of Equatorial Guinea and Grants(current US$) of Togo?
Your answer should be very brief. -5.04e+07. In the year 1998, what is the difference between the Grants(current US$) in Equatorial Guinea and Grants(current US$) in Vietnam?
Offer a terse response. -2.23e+08. In the year 1998, what is the difference between the Grants(current US$) of Togo and Grants(current US$) of Vietnam?
Provide a succinct answer. -1.73e+08. In the year 1999, what is the difference between the Grants(current US$) in Bosnia and Herzegovina and Grants(current US$) in Equatorial Guinea?
Ensure brevity in your answer.  1.06e+09. In the year 1999, what is the difference between the Grants(current US$) of Bosnia and Herzegovina and Grants(current US$) of Togo?
Offer a very short reply. 1.02e+09. In the year 1999, what is the difference between the Grants(current US$) of Bosnia and Herzegovina and Grants(current US$) of Vietnam?
Provide a short and direct response. 8.05e+08. In the year 1999, what is the difference between the Grants(current US$) of Equatorial Guinea and Grants(current US$) of Togo?
Make the answer very short. -3.19e+07. In the year 1999, what is the difference between the Grants(current US$) of Equatorial Guinea and Grants(current US$) of Vietnam?
Give a very brief answer. -2.51e+08. In the year 1999, what is the difference between the Grants(current US$) of Togo and Grants(current US$) of Vietnam?
Offer a very short reply. -2.19e+08. In the year 2000, what is the difference between the Grants(current US$) in Bosnia and Herzegovina and Grants(current US$) in Equatorial Guinea?
Make the answer very short. 5.54e+08. In the year 2000, what is the difference between the Grants(current US$) in Bosnia and Herzegovina and Grants(current US$) in Togo?
Offer a very short reply. 5.23e+08. In the year 2000, what is the difference between the Grants(current US$) of Bosnia and Herzegovina and Grants(current US$) of Vietnam?
Your answer should be compact. 3.36e+08. In the year 2000, what is the difference between the Grants(current US$) in Equatorial Guinea and Grants(current US$) in Togo?
Your answer should be very brief. -3.09e+07. In the year 2000, what is the difference between the Grants(current US$) of Equatorial Guinea and Grants(current US$) of Vietnam?
Offer a very short reply. -2.18e+08. In the year 2000, what is the difference between the Grants(current US$) in Togo and Grants(current US$) in Vietnam?
Keep it short and to the point. -1.87e+08. In the year 2001, what is the difference between the Grants(current US$) in Bosnia and Herzegovina and Grants(current US$) in Equatorial Guinea?
Make the answer very short. 4.17e+08. In the year 2001, what is the difference between the Grants(current US$) of Bosnia and Herzegovina and Grants(current US$) of Togo?
Make the answer very short. 3.99e+08. In the year 2001, what is the difference between the Grants(current US$) of Bosnia and Herzegovina and Grants(current US$) of Vietnam?
Keep it short and to the point. 1.68e+08. In the year 2001, what is the difference between the Grants(current US$) in Equatorial Guinea and Grants(current US$) in Togo?
Provide a short and direct response. -1.75e+07. In the year 2001, what is the difference between the Grants(current US$) of Equatorial Guinea and Grants(current US$) of Vietnam?
Your answer should be compact. -2.49e+08. In the year 2001, what is the difference between the Grants(current US$) in Togo and Grants(current US$) in Vietnam?
Your response must be concise. -2.32e+08. In the year 2002, what is the difference between the Grants(current US$) of Bosnia and Herzegovina and Grants(current US$) of Equatorial Guinea?
Your response must be concise. 3.13e+08. In the year 2002, what is the difference between the Grants(current US$) of Bosnia and Herzegovina and Grants(current US$) of Togo?
Your answer should be compact. 2.93e+08. In the year 2002, what is the difference between the Grants(current US$) of Bosnia and Herzegovina and Grants(current US$) of Vietnam?
Provide a short and direct response. 7.79e+07. In the year 2002, what is the difference between the Grants(current US$) of Equatorial Guinea and Grants(current US$) of Togo?
Provide a succinct answer. -1.99e+07. In the year 2002, what is the difference between the Grants(current US$) of Equatorial Guinea and Grants(current US$) of Vietnam?
Your response must be concise. -2.35e+08. In the year 2002, what is the difference between the Grants(current US$) of Togo and Grants(current US$) of Vietnam?
Your response must be concise. -2.15e+08. In the year 2003, what is the difference between the Grants(current US$) in Bosnia and Herzegovina and Grants(current US$) in Equatorial Guinea?
Your answer should be compact. 3.07e+08. In the year 2003, what is the difference between the Grants(current US$) of Bosnia and Herzegovina and Grants(current US$) of Togo?
Your answer should be compact. 2.81e+08. In the year 2003, what is the difference between the Grants(current US$) in Bosnia and Herzegovina and Grants(current US$) in Vietnam?
Your answer should be very brief. -7.37e+06. In the year 2003, what is the difference between the Grants(current US$) of Equatorial Guinea and Grants(current US$) of Togo?
Offer a terse response. -2.52e+07. In the year 2003, what is the difference between the Grants(current US$) of Equatorial Guinea and Grants(current US$) of Vietnam?
Your response must be concise. -3.14e+08. In the year 2003, what is the difference between the Grants(current US$) in Togo and Grants(current US$) in Vietnam?
Your response must be concise. -2.89e+08. In the year 2004, what is the difference between the Grants(current US$) in Bosnia and Herzegovina and Grants(current US$) in Equatorial Guinea?
Make the answer very short. 2.54e+08. In the year 2004, what is the difference between the Grants(current US$) of Bosnia and Herzegovina and Grants(current US$) of Togo?
Your answer should be very brief. 2.46e+08. In the year 2004, what is the difference between the Grants(current US$) of Bosnia and Herzegovina and Grants(current US$) of Vietnam?
Provide a short and direct response. -1.22e+08. In the year 2004, what is the difference between the Grants(current US$) in Equatorial Guinea and Grants(current US$) in Togo?
Offer a terse response. -7.84e+06. In the year 2004, what is the difference between the Grants(current US$) of Equatorial Guinea and Grants(current US$) of Vietnam?
Ensure brevity in your answer.  -3.76e+08. In the year 2004, what is the difference between the Grants(current US$) in Togo and Grants(current US$) in Vietnam?
Keep it short and to the point. -3.68e+08. In the year 2005, what is the difference between the Grants(current US$) of Bosnia and Herzegovina and Grants(current US$) of Equatorial Guinea?
Your answer should be very brief. 2.61e+08. In the year 2005, what is the difference between the Grants(current US$) of Bosnia and Herzegovina and Grants(current US$) of Togo?
Your answer should be very brief. 2.30e+08. In the year 2005, what is the difference between the Grants(current US$) of Bosnia and Herzegovina and Grants(current US$) of Vietnam?
Ensure brevity in your answer.  -2.25e+08. In the year 2005, what is the difference between the Grants(current US$) of Equatorial Guinea and Grants(current US$) of Togo?
Make the answer very short. -3.10e+07. In the year 2005, what is the difference between the Grants(current US$) of Equatorial Guinea and Grants(current US$) of Vietnam?
Provide a succinct answer. -4.87e+08. In the year 2005, what is the difference between the Grants(current US$) in Togo and Grants(current US$) in Vietnam?
Provide a short and direct response. -4.56e+08. What is the ratio of the Grants(current US$) of Bosnia and Herzegovina in 1998 to that in 1999?
Your answer should be compact. 0.48. What is the ratio of the Grants(current US$) in Equatorial Guinea in 1998 to that in 1999?
Provide a succinct answer. 1.15. What is the ratio of the Grants(current US$) of Togo in 1998 to that in 1999?
Provide a short and direct response. 1.47. What is the ratio of the Grants(current US$) in Vietnam in 1998 to that in 1999?
Provide a short and direct response. 0.9. What is the ratio of the Grants(current US$) of Bosnia and Herzegovina in 1998 to that in 2000?
Your answer should be compact. 0.89. What is the ratio of the Grants(current US$) in Equatorial Guinea in 1998 to that in 2000?
Your answer should be very brief. 0.72. What is the ratio of the Grants(current US$) in Togo in 1998 to that in 2000?
Keep it short and to the point. 1.3. What is the ratio of the Grants(current US$) of Bosnia and Herzegovina in 1998 to that in 2001?
Provide a short and direct response. 1.18. What is the ratio of the Grants(current US$) of Equatorial Guinea in 1998 to that in 2001?
Provide a short and direct response. 0.84. What is the ratio of the Grants(current US$) of Togo in 1998 to that in 2001?
Keep it short and to the point. 1.93. What is the ratio of the Grants(current US$) in Vietnam in 1998 to that in 2001?
Your answer should be very brief. 0.89. What is the ratio of the Grants(current US$) of Bosnia and Herzegovina in 1998 to that in 2002?
Your response must be concise. 1.56. What is the ratio of the Grants(current US$) in Equatorial Guinea in 1998 to that in 2002?
Provide a short and direct response. 1.04. What is the ratio of the Grants(current US$) in Togo in 1998 to that in 2002?
Your answer should be very brief. 1.96. What is the ratio of the Grants(current US$) in Vietnam in 1998 to that in 2002?
Offer a very short reply. 0.95. What is the ratio of the Grants(current US$) in Bosnia and Herzegovina in 1998 to that in 2003?
Offer a very short reply. 1.6. What is the ratio of the Grants(current US$) of Equatorial Guinea in 1998 to that in 2003?
Ensure brevity in your answer.  1.12. What is the ratio of the Grants(current US$) in Togo in 1998 to that in 2003?
Keep it short and to the point. 1.72. What is the ratio of the Grants(current US$) of Vietnam in 1998 to that in 2003?
Keep it short and to the point. 0.73. What is the ratio of the Grants(current US$) of Bosnia and Herzegovina in 1998 to that in 2004?
Keep it short and to the point. 1.74. What is the ratio of the Grants(current US$) of Equatorial Guinea in 1998 to that in 2004?
Offer a very short reply. 0.34. What is the ratio of the Grants(current US$) in Togo in 1998 to that in 2004?
Ensure brevity in your answer.  1.39. What is the ratio of the Grants(current US$) of Vietnam in 1998 to that in 2004?
Your answer should be very brief. 0.57. What is the ratio of the Grants(current US$) of Bosnia and Herzegovina in 1998 to that in 2005?
Give a very brief answer. 1.77. What is the ratio of the Grants(current US$) in Equatorial Guinea in 1998 to that in 2005?
Provide a short and direct response. 0.5. What is the ratio of the Grants(current US$) of Vietnam in 1998 to that in 2005?
Make the answer very short. 0.46. What is the ratio of the Grants(current US$) in Bosnia and Herzegovina in 1999 to that in 2000?
Give a very brief answer. 1.87. What is the ratio of the Grants(current US$) of Equatorial Guinea in 1999 to that in 2000?
Offer a terse response. 0.63. What is the ratio of the Grants(current US$) of Togo in 1999 to that in 2000?
Make the answer very short. 0.89. What is the ratio of the Grants(current US$) in Vietnam in 1999 to that in 2000?
Give a very brief answer. 1.11. What is the ratio of the Grants(current US$) of Bosnia and Herzegovina in 1999 to that in 2001?
Provide a short and direct response. 2.47. What is the ratio of the Grants(current US$) of Equatorial Guinea in 1999 to that in 2001?
Give a very brief answer. 0.73. What is the ratio of the Grants(current US$) in Togo in 1999 to that in 2001?
Ensure brevity in your answer.  1.31. What is the ratio of the Grants(current US$) in Bosnia and Herzegovina in 1999 to that in 2002?
Make the answer very short. 3.28. What is the ratio of the Grants(current US$) of Equatorial Guinea in 1999 to that in 2002?
Your answer should be very brief. 0.91. What is the ratio of the Grants(current US$) in Togo in 1999 to that in 2002?
Provide a succinct answer. 1.34. What is the ratio of the Grants(current US$) of Vietnam in 1999 to that in 2002?
Provide a short and direct response. 1.06. What is the ratio of the Grants(current US$) in Bosnia and Herzegovina in 1999 to that in 2003?
Your response must be concise. 3.36. What is the ratio of the Grants(current US$) of Equatorial Guinea in 1999 to that in 2003?
Provide a short and direct response. 0.97. What is the ratio of the Grants(current US$) of Togo in 1999 to that in 2003?
Keep it short and to the point. 1.17. What is the ratio of the Grants(current US$) in Vietnam in 1999 to that in 2003?
Make the answer very short. 0.81. What is the ratio of the Grants(current US$) of Bosnia and Herzegovina in 1999 to that in 2004?
Offer a very short reply. 3.66. What is the ratio of the Grants(current US$) in Equatorial Guinea in 1999 to that in 2004?
Offer a very short reply. 0.3. What is the ratio of the Grants(current US$) in Togo in 1999 to that in 2004?
Offer a terse response. 0.94. What is the ratio of the Grants(current US$) in Vietnam in 1999 to that in 2004?
Ensure brevity in your answer.  0.63. What is the ratio of the Grants(current US$) in Bosnia and Herzegovina in 1999 to that in 2005?
Give a very brief answer. 3.71. What is the ratio of the Grants(current US$) in Equatorial Guinea in 1999 to that in 2005?
Offer a very short reply. 0.43. What is the ratio of the Grants(current US$) in Togo in 1999 to that in 2005?
Keep it short and to the point. 0.76. What is the ratio of the Grants(current US$) in Vietnam in 1999 to that in 2005?
Your response must be concise. 0.51. What is the ratio of the Grants(current US$) of Bosnia and Herzegovina in 2000 to that in 2001?
Provide a short and direct response. 1.32. What is the ratio of the Grants(current US$) in Equatorial Guinea in 2000 to that in 2001?
Your answer should be very brief. 1.16. What is the ratio of the Grants(current US$) in Togo in 2000 to that in 2001?
Your answer should be compact. 1.48. What is the ratio of the Grants(current US$) of Vietnam in 2000 to that in 2001?
Keep it short and to the point. 0.89. What is the ratio of the Grants(current US$) of Bosnia and Herzegovina in 2000 to that in 2002?
Offer a very short reply. 1.75. What is the ratio of the Grants(current US$) of Equatorial Guinea in 2000 to that in 2002?
Provide a short and direct response. 1.43. What is the ratio of the Grants(current US$) of Togo in 2000 to that in 2002?
Ensure brevity in your answer.  1.51. What is the ratio of the Grants(current US$) in Vietnam in 2000 to that in 2002?
Your response must be concise. 0.95. What is the ratio of the Grants(current US$) of Bosnia and Herzegovina in 2000 to that in 2003?
Provide a succinct answer. 1.8. What is the ratio of the Grants(current US$) in Equatorial Guinea in 2000 to that in 2003?
Offer a terse response. 1.54. What is the ratio of the Grants(current US$) of Togo in 2000 to that in 2003?
Keep it short and to the point. 1.33. What is the ratio of the Grants(current US$) in Vietnam in 2000 to that in 2003?
Provide a succinct answer. 0.72. What is the ratio of the Grants(current US$) in Bosnia and Herzegovina in 2000 to that in 2004?
Your answer should be compact. 1.96. What is the ratio of the Grants(current US$) of Equatorial Guinea in 2000 to that in 2004?
Provide a succinct answer. 0.47. What is the ratio of the Grants(current US$) of Togo in 2000 to that in 2004?
Offer a very short reply. 1.07. What is the ratio of the Grants(current US$) in Vietnam in 2000 to that in 2004?
Your response must be concise. 0.57. What is the ratio of the Grants(current US$) in Bosnia and Herzegovina in 2000 to that in 2005?
Your answer should be very brief. 1.99. What is the ratio of the Grants(current US$) in Equatorial Guinea in 2000 to that in 2005?
Your answer should be very brief. 0.69. What is the ratio of the Grants(current US$) in Togo in 2000 to that in 2005?
Your response must be concise. 0.85. What is the ratio of the Grants(current US$) of Vietnam in 2000 to that in 2005?
Make the answer very short. 0.46. What is the ratio of the Grants(current US$) in Bosnia and Herzegovina in 2001 to that in 2002?
Offer a very short reply. 1.33. What is the ratio of the Grants(current US$) in Equatorial Guinea in 2001 to that in 2002?
Your answer should be compact. 1.24. What is the ratio of the Grants(current US$) of Togo in 2001 to that in 2002?
Offer a terse response. 1.02. What is the ratio of the Grants(current US$) in Vietnam in 2001 to that in 2002?
Provide a short and direct response. 1.07. What is the ratio of the Grants(current US$) of Bosnia and Herzegovina in 2001 to that in 2003?
Your response must be concise. 1.36. What is the ratio of the Grants(current US$) in Equatorial Guinea in 2001 to that in 2003?
Your answer should be very brief. 1.33. What is the ratio of the Grants(current US$) in Togo in 2001 to that in 2003?
Keep it short and to the point. 0.89. What is the ratio of the Grants(current US$) of Vietnam in 2001 to that in 2003?
Give a very brief answer. 0.81. What is the ratio of the Grants(current US$) in Bosnia and Herzegovina in 2001 to that in 2004?
Your response must be concise. 1.48. What is the ratio of the Grants(current US$) of Equatorial Guinea in 2001 to that in 2004?
Your answer should be very brief. 0.41. What is the ratio of the Grants(current US$) in Togo in 2001 to that in 2004?
Your answer should be compact. 0.72. What is the ratio of the Grants(current US$) of Vietnam in 2001 to that in 2004?
Offer a very short reply. 0.64. What is the ratio of the Grants(current US$) in Bosnia and Herzegovina in 2001 to that in 2005?
Provide a short and direct response. 1.5. What is the ratio of the Grants(current US$) in Equatorial Guinea in 2001 to that in 2005?
Provide a succinct answer. 0.59. What is the ratio of the Grants(current US$) in Togo in 2001 to that in 2005?
Provide a short and direct response. 0.58. What is the ratio of the Grants(current US$) of Vietnam in 2001 to that in 2005?
Your answer should be very brief. 0.52. What is the ratio of the Grants(current US$) in Bosnia and Herzegovina in 2002 to that in 2003?
Keep it short and to the point. 1.02. What is the ratio of the Grants(current US$) in Equatorial Guinea in 2002 to that in 2003?
Keep it short and to the point. 1.08. What is the ratio of the Grants(current US$) in Togo in 2002 to that in 2003?
Offer a very short reply. 0.88. What is the ratio of the Grants(current US$) in Vietnam in 2002 to that in 2003?
Offer a terse response. 0.76. What is the ratio of the Grants(current US$) of Bosnia and Herzegovina in 2002 to that in 2004?
Your response must be concise. 1.12. What is the ratio of the Grants(current US$) in Equatorial Guinea in 2002 to that in 2004?
Ensure brevity in your answer.  0.33. What is the ratio of the Grants(current US$) in Togo in 2002 to that in 2004?
Ensure brevity in your answer.  0.71. What is the ratio of the Grants(current US$) of Vietnam in 2002 to that in 2004?
Ensure brevity in your answer.  0.6. What is the ratio of the Grants(current US$) of Bosnia and Herzegovina in 2002 to that in 2005?
Offer a terse response. 1.13. What is the ratio of the Grants(current US$) of Equatorial Guinea in 2002 to that in 2005?
Provide a succinct answer. 0.48. What is the ratio of the Grants(current US$) in Togo in 2002 to that in 2005?
Provide a short and direct response. 0.57. What is the ratio of the Grants(current US$) in Vietnam in 2002 to that in 2005?
Offer a terse response. 0.48. What is the ratio of the Grants(current US$) in Bosnia and Herzegovina in 2003 to that in 2004?
Your answer should be very brief. 1.09. What is the ratio of the Grants(current US$) in Equatorial Guinea in 2003 to that in 2004?
Offer a very short reply. 0.31. What is the ratio of the Grants(current US$) of Togo in 2003 to that in 2004?
Provide a short and direct response. 0.8. What is the ratio of the Grants(current US$) of Vietnam in 2003 to that in 2004?
Provide a short and direct response. 0.79. What is the ratio of the Grants(current US$) of Bosnia and Herzegovina in 2003 to that in 2005?
Your response must be concise. 1.11. What is the ratio of the Grants(current US$) of Equatorial Guinea in 2003 to that in 2005?
Offer a very short reply. 0.44. What is the ratio of the Grants(current US$) in Togo in 2003 to that in 2005?
Give a very brief answer. 0.64. What is the ratio of the Grants(current US$) of Vietnam in 2003 to that in 2005?
Give a very brief answer. 0.64. What is the ratio of the Grants(current US$) in Bosnia and Herzegovina in 2004 to that in 2005?
Your answer should be very brief. 1.01. What is the ratio of the Grants(current US$) in Equatorial Guinea in 2004 to that in 2005?
Your response must be concise. 1.45. What is the ratio of the Grants(current US$) in Togo in 2004 to that in 2005?
Your answer should be very brief. 0.8. What is the ratio of the Grants(current US$) in Vietnam in 2004 to that in 2005?
Ensure brevity in your answer.  0.81. What is the difference between the highest and the second highest Grants(current US$) of Bosnia and Herzegovina?
Give a very brief answer. 4.96e+08. What is the difference between the highest and the second highest Grants(current US$) in Equatorial Guinea?
Give a very brief answer. 1.18e+07. What is the difference between the highest and the second highest Grants(current US$) in Togo?
Give a very brief answer. 6.34e+06. What is the difference between the highest and the second highest Grants(current US$) in Vietnam?
Your answer should be compact. 9.86e+07. What is the difference between the highest and the lowest Grants(current US$) in Bosnia and Herzegovina?
Provide a succinct answer. 7.80e+08. What is the difference between the highest and the lowest Grants(current US$) in Equatorial Guinea?
Give a very brief answer. 2.66e+07. What is the difference between the highest and the lowest Grants(current US$) of Togo?
Provide a short and direct response. 3.11e+07. What is the difference between the highest and the lowest Grants(current US$) in Vietnam?
Your answer should be very brief. 2.77e+08. 